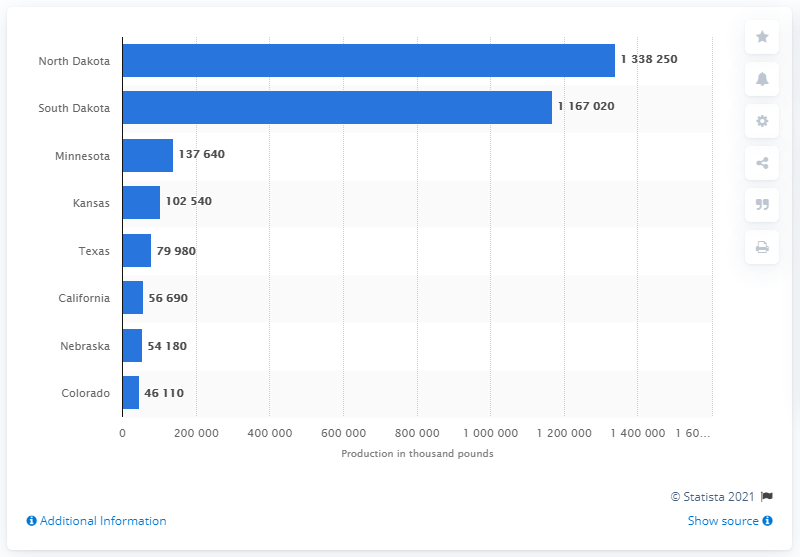Outline some significant characteristics in this image. South Dakota produced the most sunflowers in 2020. North Dakota is the state that produces the largest quantity of sunflowers. 